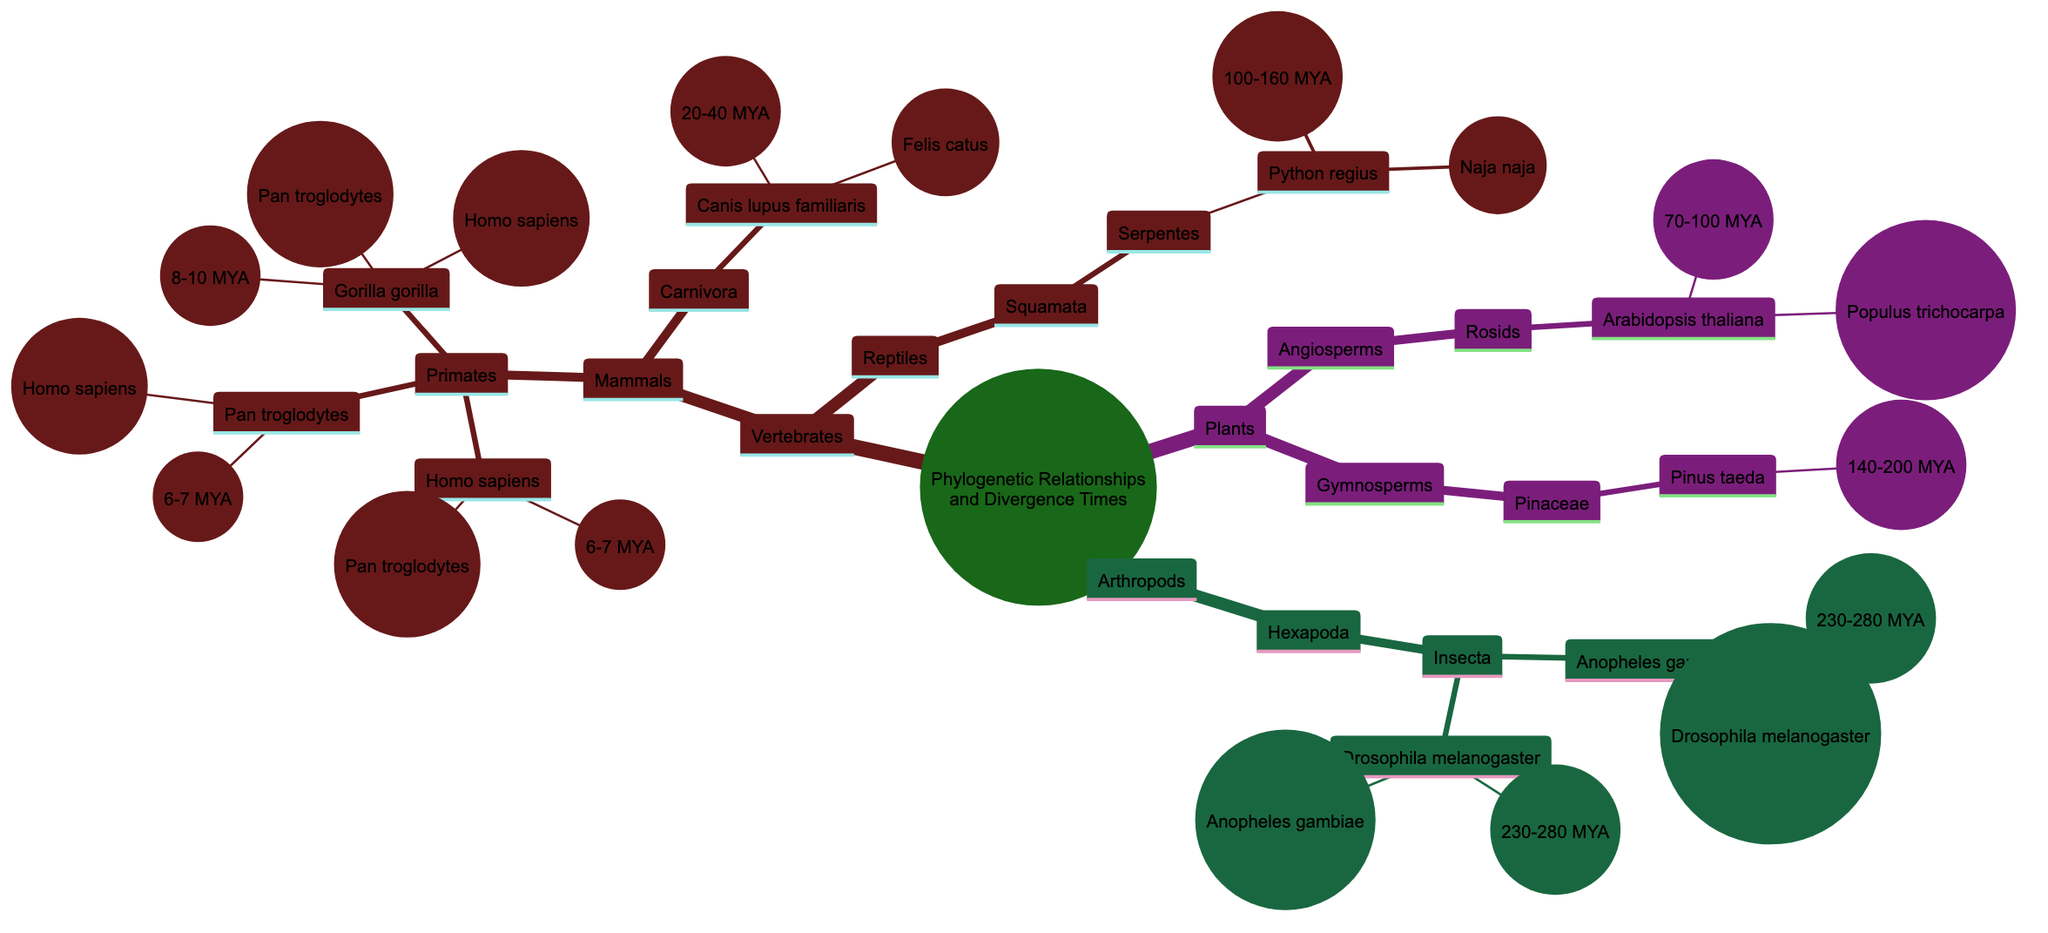What is the divergence time for Homo sapiens? The diagram indicates that Homo sapiens diverged approximately 6-7 million years ago. This information is explicitly stated next to the node for Homo sapiens.
Answer: 6-7 million years ago What two species are related to Gorilla gorilla? According to the diagram, Gorilla gorilla has relationships with both Homo sapiens and Pan troglodytes. These relationships are indicated in the connections stemming from the Gorilla gorilla node.
Answer: Homo sapiens, Pan troglodytes Which species diverged approximately 140-200 million years ago? The diagram shows that Pinus taeda diverged within the timeframe of 140-200 million years ago. This divergence time is noted alongside the Pinus taeda node.
Answer: Pinus taeda How many species are listed under the Mammals node? The diagram shows that there are three species listed under the Mammals node: Homo sapiens, Pan troglodytes, and Gorilla gorilla. By counting these species, we arrive at the answer of three.
Answer: Three Which group does Drosophila melanogaster belong to? The diagram categorizes Drosophila melanogaster within the Insecta node, which is a part of the Hexapoda group. This relationship is clearly structured in the hierarchy of the diagram.
Answer: Hexapoda What is the common relationship between Drosophila melanogaster and Anopheles gambiae? The relationship between Drosophila melanogaster and Anopheles gambiae is mutual, as both species are indicated to have a relationship with each other in the diagram. This emphasizes their connection.
Answer: Drosophila melanogaster, Anopheles gambiae What is the divergence time of Serpentes? The diagram specifies that the divergence time for Python regius, which is a part of the Serpentes group, is between 100-160 million years ago. Thus, we can conclude this timeframe corresponds to the Serpentes group as well.
Answer: 100-160 million years ago How many total groups are classified under Plants? The diagram classifies Plants into two main groups: Angiosperms and Gymnosperms. By reviewing the nodes, we determine that there are exactly two groups below the main Plants node.
Answer: Two 